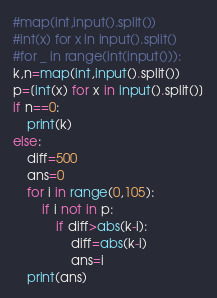Convert code to text. <code><loc_0><loc_0><loc_500><loc_500><_Python_>#map(int,input().split())
#int(x) for x in input().split()
#for _ in range(int(input())):
k,n=map(int,input().split())
p=[int(x) for x in input().split()]
if n==0:
	print(k)
else:
	diff=500
	ans=0
	for i in range(0,105):
		if i not in p:
			if diff>abs(k-i):
				diff=abs(k-i)
				ans=i
	print(ans)



</code> 